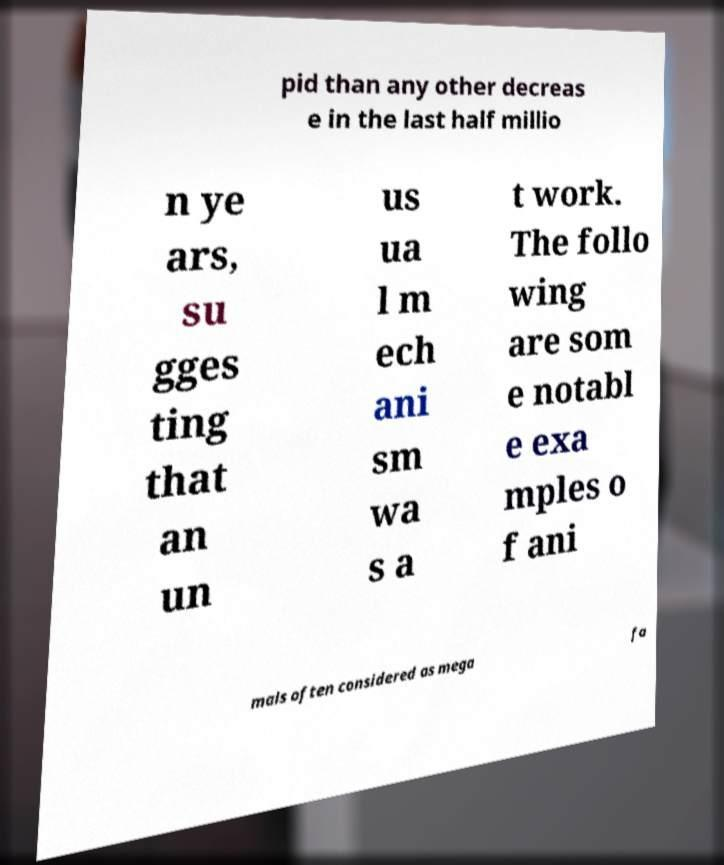I need the written content from this picture converted into text. Can you do that? pid than any other decreas e in the last half millio n ye ars, su gges ting that an un us ua l m ech ani sm wa s a t work. The follo wing are som e notabl e exa mples o f ani mals often considered as mega fa 